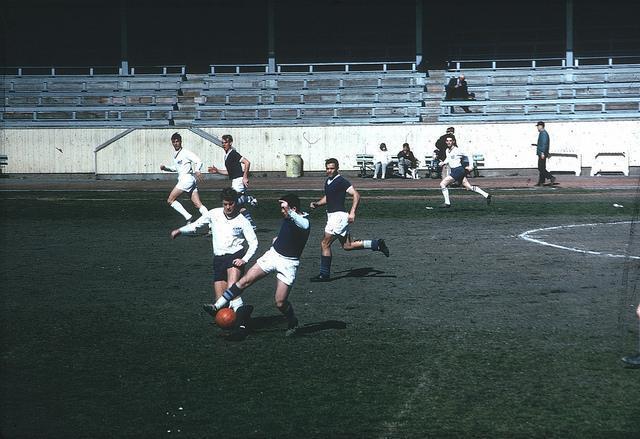How many benches can you see?
Give a very brief answer. 2. How many people can you see?
Give a very brief answer. 4. How many glasses are full of orange juice?
Give a very brief answer. 0. 